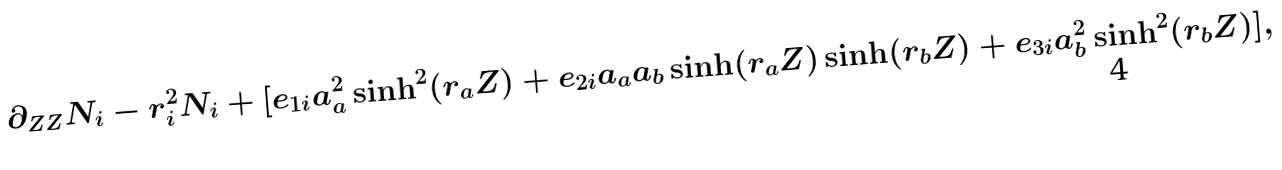Convert formula to latex. <formula><loc_0><loc_0><loc_500><loc_500>\partial _ { Z Z } N _ { i } - r _ { i } ^ { 2 } N _ { i } + [ e _ { 1 i } a _ { a } ^ { 2 } \sinh ^ { 2 } ( r _ { a } Z ) + e _ { 2 i } a _ { a } a _ { b } \sinh ( r _ { a } Z ) \sinh ( r _ { b } Z ) + e _ { 3 i } a _ { b } ^ { 2 } \sinh ^ { 2 } ( r _ { b } Z ) ] ,</formula> 